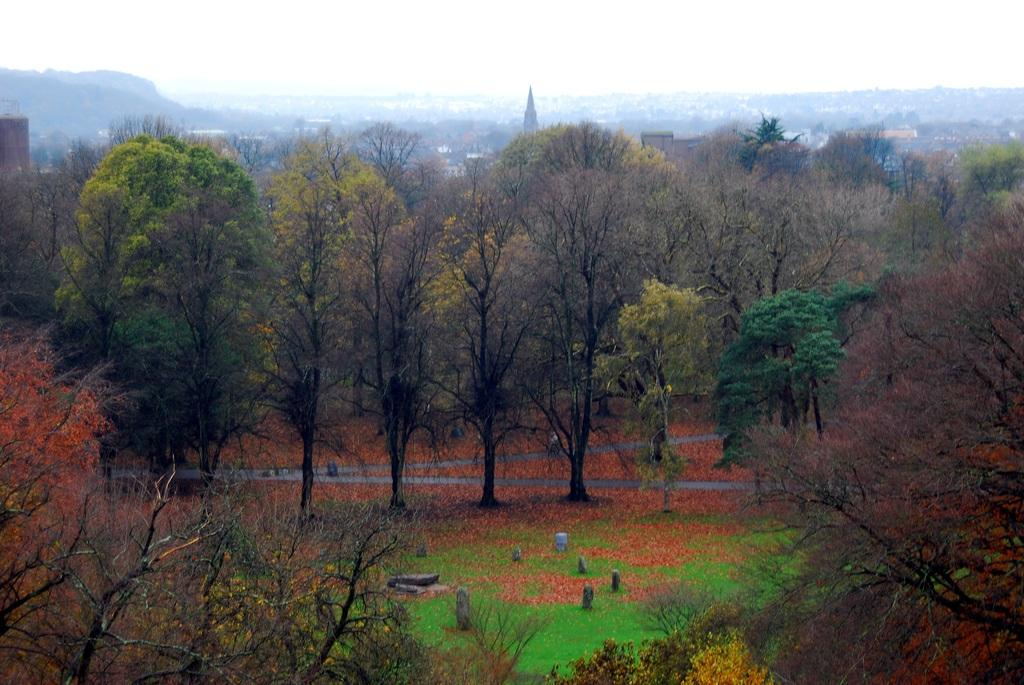What type of vegetation can be seen in the image? There are trees and grass in the image. What type of structures are visible in the image? There are houses and a tower in the image. What natural landmark can be seen in the image? There are mountains in the image. What is visible at the top of the image? The sky is visible at the top of the image. In which setting is the image taken? The image is taken in a forest setting. What type of juice is being served in the image? There is no juice present in the image; it is a forest setting with trees, grass, houses, a tower, mountains, and the sky. What type of shoes are the trees wearing in the image? Trees do not wear shoes, as they are not living beings capable of wearing clothing or accessories. 